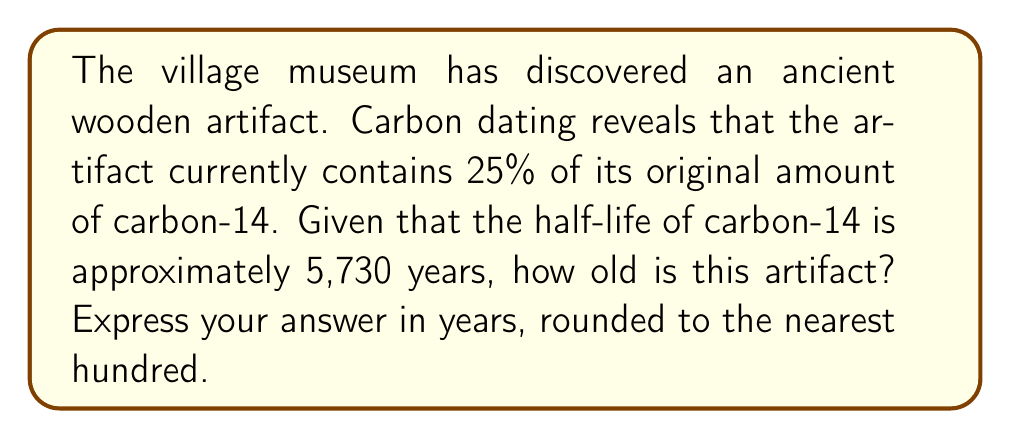What is the answer to this math problem? To solve this problem, we'll use the exponential decay formula:

$$A(t) = A_0 \cdot (1/2)^{t/h}$$

Where:
$A(t)$ is the amount remaining after time $t$
$A_0$ is the initial amount
$h$ is the half-life
$t$ is the time elapsed

We know:
$A(t)/A_0 = 0.25$ (25% remaining)
$h = 5,730$ years

Let's substitute these values into the formula:

$$0.25 = (1/2)^{t/5730}$$

Now, we need to solve for $t$. Let's use logarithms:

$$\log_2(0.25) = t/5730$$

$$\log_2(1/4) = t/5730$$

$$-2 = t/5730$$

Multiply both sides by 5730:

$$t = -2 \cdot 5730 = -11,460$$

The negative sign indicates time in the past. Therefore, the artifact is approximately 11,460 years old.

Rounding to the nearest hundred years:

$$11,460 \approx 11,500 \text{ years}$$
Answer: 11,500 years 